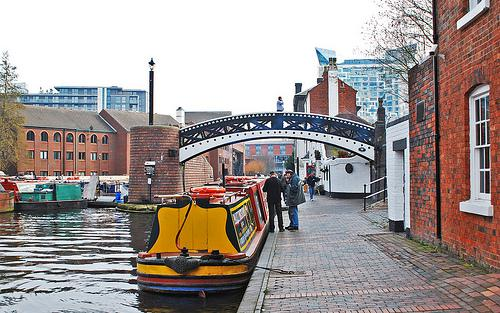Question: what color is the sky?
Choices:
A. Blue.
B. White.
C. Gray.
D. Black.
Answer with the letter. Answer: C Question: what is in the channel?
Choices:
A. Bouy.
B. Submarines.
C. Boats.
D. Jet skis.
Answer with the letter. Answer: C Question: when was this picture taken?
Choices:
A. During the night.
B. During the day.
C. During the morning.
D. During the afternoon.
Answer with the letter. Answer: B Question: who is on the bridge?
Choices:
A. A woman with a map.
B. A boy with a balloon.
C. A girl with a doll.
D. The man on his phone.
Answer with the letter. Answer: D Question: what is the building on the right made of?
Choices:
A. Concrete.
B. Wood.
C. Bricks.
D. Steel.
Answer with the letter. Answer: C Question: how many men are standing next the red boat?
Choices:
A. Two.
B. Three.
C. One.
D. Four.
Answer with the letter. Answer: A 